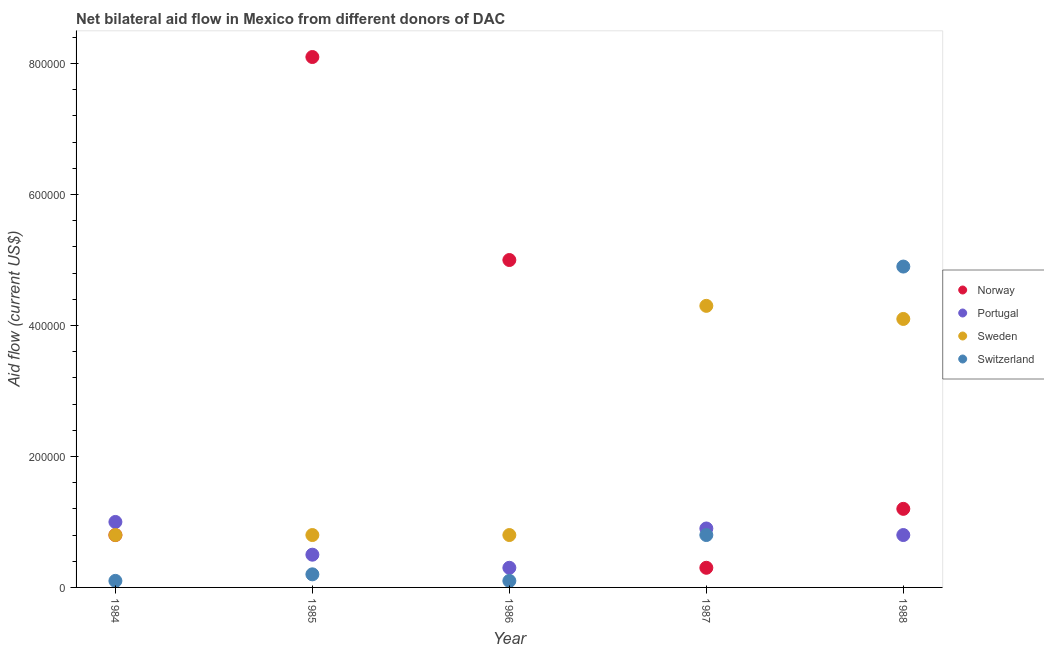Is the number of dotlines equal to the number of legend labels?
Your answer should be compact. Yes. What is the amount of aid given by norway in 1988?
Offer a terse response. 1.20e+05. Across all years, what is the maximum amount of aid given by norway?
Your answer should be very brief. 8.10e+05. Across all years, what is the minimum amount of aid given by switzerland?
Give a very brief answer. 10000. What is the total amount of aid given by portugal in the graph?
Give a very brief answer. 3.50e+05. What is the difference between the amount of aid given by sweden in 1984 and that in 1985?
Ensure brevity in your answer.  0. What is the difference between the amount of aid given by portugal in 1987 and the amount of aid given by sweden in 1986?
Provide a succinct answer. 10000. What is the average amount of aid given by sweden per year?
Provide a short and direct response. 2.16e+05. In the year 1988, what is the difference between the amount of aid given by portugal and amount of aid given by switzerland?
Provide a succinct answer. -4.10e+05. Is the amount of aid given by sweden in 1987 less than that in 1988?
Give a very brief answer. No. What is the difference between the highest and the second highest amount of aid given by portugal?
Give a very brief answer. 10000. What is the difference between the highest and the lowest amount of aid given by sweden?
Your answer should be compact. 3.50e+05. In how many years, is the amount of aid given by portugal greater than the average amount of aid given by portugal taken over all years?
Give a very brief answer. 3. Is the sum of the amount of aid given by norway in 1984 and 1987 greater than the maximum amount of aid given by switzerland across all years?
Your response must be concise. No. Is it the case that in every year, the sum of the amount of aid given by sweden and amount of aid given by norway is greater than the sum of amount of aid given by portugal and amount of aid given by switzerland?
Offer a terse response. Yes. Is the amount of aid given by switzerland strictly greater than the amount of aid given by sweden over the years?
Make the answer very short. No. Are the values on the major ticks of Y-axis written in scientific E-notation?
Give a very brief answer. No. Does the graph contain any zero values?
Your answer should be compact. No. Does the graph contain grids?
Offer a very short reply. No. Where does the legend appear in the graph?
Your answer should be very brief. Center right. How are the legend labels stacked?
Make the answer very short. Vertical. What is the title of the graph?
Offer a very short reply. Net bilateral aid flow in Mexico from different donors of DAC. Does "Debt policy" appear as one of the legend labels in the graph?
Provide a succinct answer. No. What is the label or title of the X-axis?
Provide a succinct answer. Year. What is the label or title of the Y-axis?
Your answer should be compact. Aid flow (current US$). What is the Aid flow (current US$) of Switzerland in 1984?
Ensure brevity in your answer.  10000. What is the Aid flow (current US$) of Norway in 1985?
Offer a very short reply. 8.10e+05. What is the Aid flow (current US$) in Sweden in 1985?
Ensure brevity in your answer.  8.00e+04. What is the Aid flow (current US$) of Norway in 1986?
Your response must be concise. 5.00e+05. What is the Aid flow (current US$) in Sweden in 1986?
Give a very brief answer. 8.00e+04. What is the Aid flow (current US$) in Switzerland in 1986?
Offer a very short reply. 10000. What is the Aid flow (current US$) in Norway in 1988?
Provide a succinct answer. 1.20e+05. What is the Aid flow (current US$) of Portugal in 1988?
Give a very brief answer. 8.00e+04. Across all years, what is the maximum Aid flow (current US$) of Norway?
Your answer should be very brief. 8.10e+05. Across all years, what is the minimum Aid flow (current US$) of Portugal?
Make the answer very short. 3.00e+04. What is the total Aid flow (current US$) in Norway in the graph?
Your answer should be very brief. 1.54e+06. What is the total Aid flow (current US$) of Portugal in the graph?
Your response must be concise. 3.50e+05. What is the total Aid flow (current US$) of Sweden in the graph?
Your answer should be very brief. 1.08e+06. What is the difference between the Aid flow (current US$) in Norway in 1984 and that in 1985?
Provide a succinct answer. -7.30e+05. What is the difference between the Aid flow (current US$) in Sweden in 1984 and that in 1985?
Give a very brief answer. 0. What is the difference between the Aid flow (current US$) in Switzerland in 1984 and that in 1985?
Provide a succinct answer. -10000. What is the difference between the Aid flow (current US$) in Norway in 1984 and that in 1986?
Offer a terse response. -4.20e+05. What is the difference between the Aid flow (current US$) in Portugal in 1984 and that in 1986?
Make the answer very short. 7.00e+04. What is the difference between the Aid flow (current US$) of Norway in 1984 and that in 1987?
Offer a terse response. 5.00e+04. What is the difference between the Aid flow (current US$) of Portugal in 1984 and that in 1987?
Offer a terse response. 10000. What is the difference between the Aid flow (current US$) of Sweden in 1984 and that in 1987?
Offer a terse response. -3.50e+05. What is the difference between the Aid flow (current US$) of Switzerland in 1984 and that in 1987?
Your response must be concise. -7.00e+04. What is the difference between the Aid flow (current US$) in Norway in 1984 and that in 1988?
Your response must be concise. -4.00e+04. What is the difference between the Aid flow (current US$) of Sweden in 1984 and that in 1988?
Offer a terse response. -3.30e+05. What is the difference between the Aid flow (current US$) in Switzerland in 1984 and that in 1988?
Ensure brevity in your answer.  -4.80e+05. What is the difference between the Aid flow (current US$) of Norway in 1985 and that in 1986?
Provide a short and direct response. 3.10e+05. What is the difference between the Aid flow (current US$) of Switzerland in 1985 and that in 1986?
Provide a short and direct response. 10000. What is the difference between the Aid flow (current US$) of Norway in 1985 and that in 1987?
Make the answer very short. 7.80e+05. What is the difference between the Aid flow (current US$) in Sweden in 1985 and that in 1987?
Offer a very short reply. -3.50e+05. What is the difference between the Aid flow (current US$) in Switzerland in 1985 and that in 1987?
Your response must be concise. -6.00e+04. What is the difference between the Aid flow (current US$) of Norway in 1985 and that in 1988?
Your answer should be very brief. 6.90e+05. What is the difference between the Aid flow (current US$) in Sweden in 1985 and that in 1988?
Make the answer very short. -3.30e+05. What is the difference between the Aid flow (current US$) in Switzerland in 1985 and that in 1988?
Give a very brief answer. -4.70e+05. What is the difference between the Aid flow (current US$) of Portugal in 1986 and that in 1987?
Provide a succinct answer. -6.00e+04. What is the difference between the Aid flow (current US$) of Sweden in 1986 and that in 1987?
Keep it short and to the point. -3.50e+05. What is the difference between the Aid flow (current US$) of Portugal in 1986 and that in 1988?
Keep it short and to the point. -5.00e+04. What is the difference between the Aid flow (current US$) in Sweden in 1986 and that in 1988?
Keep it short and to the point. -3.30e+05. What is the difference between the Aid flow (current US$) in Switzerland in 1986 and that in 1988?
Provide a short and direct response. -4.80e+05. What is the difference between the Aid flow (current US$) in Norway in 1987 and that in 1988?
Offer a terse response. -9.00e+04. What is the difference between the Aid flow (current US$) in Portugal in 1987 and that in 1988?
Provide a short and direct response. 10000. What is the difference between the Aid flow (current US$) of Switzerland in 1987 and that in 1988?
Give a very brief answer. -4.10e+05. What is the difference between the Aid flow (current US$) in Norway in 1984 and the Aid flow (current US$) in Portugal in 1985?
Provide a succinct answer. 3.00e+04. What is the difference between the Aid flow (current US$) of Norway in 1984 and the Aid flow (current US$) of Sweden in 1985?
Offer a terse response. 0. What is the difference between the Aid flow (current US$) of Portugal in 1984 and the Aid flow (current US$) of Sweden in 1985?
Offer a terse response. 2.00e+04. What is the difference between the Aid flow (current US$) of Sweden in 1984 and the Aid flow (current US$) of Switzerland in 1985?
Offer a terse response. 6.00e+04. What is the difference between the Aid flow (current US$) of Norway in 1984 and the Aid flow (current US$) of Portugal in 1986?
Provide a succinct answer. 5.00e+04. What is the difference between the Aid flow (current US$) in Portugal in 1984 and the Aid flow (current US$) in Sweden in 1986?
Give a very brief answer. 2.00e+04. What is the difference between the Aid flow (current US$) of Portugal in 1984 and the Aid flow (current US$) of Switzerland in 1986?
Provide a short and direct response. 9.00e+04. What is the difference between the Aid flow (current US$) of Norway in 1984 and the Aid flow (current US$) of Sweden in 1987?
Make the answer very short. -3.50e+05. What is the difference between the Aid flow (current US$) of Portugal in 1984 and the Aid flow (current US$) of Sweden in 1987?
Keep it short and to the point. -3.30e+05. What is the difference between the Aid flow (current US$) of Portugal in 1984 and the Aid flow (current US$) of Switzerland in 1987?
Your response must be concise. 2.00e+04. What is the difference between the Aid flow (current US$) in Norway in 1984 and the Aid flow (current US$) in Sweden in 1988?
Offer a very short reply. -3.30e+05. What is the difference between the Aid flow (current US$) of Norway in 1984 and the Aid flow (current US$) of Switzerland in 1988?
Your answer should be compact. -4.10e+05. What is the difference between the Aid flow (current US$) in Portugal in 1984 and the Aid flow (current US$) in Sweden in 1988?
Make the answer very short. -3.10e+05. What is the difference between the Aid flow (current US$) in Portugal in 1984 and the Aid flow (current US$) in Switzerland in 1988?
Your response must be concise. -3.90e+05. What is the difference between the Aid flow (current US$) of Sweden in 1984 and the Aid flow (current US$) of Switzerland in 1988?
Provide a short and direct response. -4.10e+05. What is the difference between the Aid flow (current US$) of Norway in 1985 and the Aid flow (current US$) of Portugal in 1986?
Make the answer very short. 7.80e+05. What is the difference between the Aid flow (current US$) in Norway in 1985 and the Aid flow (current US$) in Sweden in 1986?
Your response must be concise. 7.30e+05. What is the difference between the Aid flow (current US$) of Portugal in 1985 and the Aid flow (current US$) of Sweden in 1986?
Your answer should be very brief. -3.00e+04. What is the difference between the Aid flow (current US$) of Portugal in 1985 and the Aid flow (current US$) of Switzerland in 1986?
Offer a very short reply. 4.00e+04. What is the difference between the Aid flow (current US$) of Norway in 1985 and the Aid flow (current US$) of Portugal in 1987?
Your response must be concise. 7.20e+05. What is the difference between the Aid flow (current US$) of Norway in 1985 and the Aid flow (current US$) of Switzerland in 1987?
Provide a short and direct response. 7.30e+05. What is the difference between the Aid flow (current US$) of Portugal in 1985 and the Aid flow (current US$) of Sweden in 1987?
Give a very brief answer. -3.80e+05. What is the difference between the Aid flow (current US$) of Portugal in 1985 and the Aid flow (current US$) of Switzerland in 1987?
Your answer should be compact. -3.00e+04. What is the difference between the Aid flow (current US$) of Norway in 1985 and the Aid flow (current US$) of Portugal in 1988?
Provide a short and direct response. 7.30e+05. What is the difference between the Aid flow (current US$) in Norway in 1985 and the Aid flow (current US$) in Sweden in 1988?
Your response must be concise. 4.00e+05. What is the difference between the Aid flow (current US$) of Portugal in 1985 and the Aid flow (current US$) of Sweden in 1988?
Ensure brevity in your answer.  -3.60e+05. What is the difference between the Aid flow (current US$) of Portugal in 1985 and the Aid flow (current US$) of Switzerland in 1988?
Provide a short and direct response. -4.40e+05. What is the difference between the Aid flow (current US$) of Sweden in 1985 and the Aid flow (current US$) of Switzerland in 1988?
Offer a terse response. -4.10e+05. What is the difference between the Aid flow (current US$) of Portugal in 1986 and the Aid flow (current US$) of Sweden in 1987?
Make the answer very short. -4.00e+05. What is the difference between the Aid flow (current US$) in Norway in 1986 and the Aid flow (current US$) in Portugal in 1988?
Your response must be concise. 4.20e+05. What is the difference between the Aid flow (current US$) in Portugal in 1986 and the Aid flow (current US$) in Sweden in 1988?
Keep it short and to the point. -3.80e+05. What is the difference between the Aid flow (current US$) in Portugal in 1986 and the Aid flow (current US$) in Switzerland in 1988?
Offer a very short reply. -4.60e+05. What is the difference between the Aid flow (current US$) in Sweden in 1986 and the Aid flow (current US$) in Switzerland in 1988?
Provide a short and direct response. -4.10e+05. What is the difference between the Aid flow (current US$) of Norway in 1987 and the Aid flow (current US$) of Portugal in 1988?
Give a very brief answer. -5.00e+04. What is the difference between the Aid flow (current US$) in Norway in 1987 and the Aid flow (current US$) in Sweden in 1988?
Your answer should be very brief. -3.80e+05. What is the difference between the Aid flow (current US$) in Norway in 1987 and the Aid flow (current US$) in Switzerland in 1988?
Provide a short and direct response. -4.60e+05. What is the difference between the Aid flow (current US$) in Portugal in 1987 and the Aid flow (current US$) in Sweden in 1988?
Your answer should be compact. -3.20e+05. What is the difference between the Aid flow (current US$) in Portugal in 1987 and the Aid flow (current US$) in Switzerland in 1988?
Keep it short and to the point. -4.00e+05. What is the difference between the Aid flow (current US$) of Sweden in 1987 and the Aid flow (current US$) of Switzerland in 1988?
Keep it short and to the point. -6.00e+04. What is the average Aid flow (current US$) of Norway per year?
Provide a short and direct response. 3.08e+05. What is the average Aid flow (current US$) in Sweden per year?
Your response must be concise. 2.16e+05. What is the average Aid flow (current US$) in Switzerland per year?
Offer a terse response. 1.22e+05. In the year 1984, what is the difference between the Aid flow (current US$) in Norway and Aid flow (current US$) in Sweden?
Ensure brevity in your answer.  0. In the year 1984, what is the difference between the Aid flow (current US$) in Sweden and Aid flow (current US$) in Switzerland?
Your answer should be very brief. 7.00e+04. In the year 1985, what is the difference between the Aid flow (current US$) of Norway and Aid flow (current US$) of Portugal?
Ensure brevity in your answer.  7.60e+05. In the year 1985, what is the difference between the Aid flow (current US$) of Norway and Aid flow (current US$) of Sweden?
Keep it short and to the point. 7.30e+05. In the year 1985, what is the difference between the Aid flow (current US$) of Norway and Aid flow (current US$) of Switzerland?
Provide a succinct answer. 7.90e+05. In the year 1985, what is the difference between the Aid flow (current US$) of Portugal and Aid flow (current US$) of Switzerland?
Provide a short and direct response. 3.00e+04. In the year 1985, what is the difference between the Aid flow (current US$) of Sweden and Aid flow (current US$) of Switzerland?
Keep it short and to the point. 6.00e+04. In the year 1986, what is the difference between the Aid flow (current US$) in Norway and Aid flow (current US$) in Portugal?
Keep it short and to the point. 4.70e+05. In the year 1986, what is the difference between the Aid flow (current US$) in Norway and Aid flow (current US$) in Sweden?
Keep it short and to the point. 4.20e+05. In the year 1986, what is the difference between the Aid flow (current US$) of Portugal and Aid flow (current US$) of Sweden?
Make the answer very short. -5.00e+04. In the year 1987, what is the difference between the Aid flow (current US$) in Norway and Aid flow (current US$) in Portugal?
Provide a short and direct response. -6.00e+04. In the year 1987, what is the difference between the Aid flow (current US$) of Norway and Aid flow (current US$) of Sweden?
Give a very brief answer. -4.00e+05. In the year 1987, what is the difference between the Aid flow (current US$) in Norway and Aid flow (current US$) in Switzerland?
Keep it short and to the point. -5.00e+04. In the year 1987, what is the difference between the Aid flow (current US$) of Portugal and Aid flow (current US$) of Sweden?
Your answer should be compact. -3.40e+05. In the year 1987, what is the difference between the Aid flow (current US$) of Portugal and Aid flow (current US$) of Switzerland?
Your answer should be compact. 10000. In the year 1988, what is the difference between the Aid flow (current US$) in Norway and Aid flow (current US$) in Portugal?
Offer a very short reply. 4.00e+04. In the year 1988, what is the difference between the Aid flow (current US$) of Norway and Aid flow (current US$) of Sweden?
Your answer should be compact. -2.90e+05. In the year 1988, what is the difference between the Aid flow (current US$) of Norway and Aid flow (current US$) of Switzerland?
Provide a short and direct response. -3.70e+05. In the year 1988, what is the difference between the Aid flow (current US$) in Portugal and Aid flow (current US$) in Sweden?
Keep it short and to the point. -3.30e+05. In the year 1988, what is the difference between the Aid flow (current US$) in Portugal and Aid flow (current US$) in Switzerland?
Your response must be concise. -4.10e+05. In the year 1988, what is the difference between the Aid flow (current US$) of Sweden and Aid flow (current US$) of Switzerland?
Make the answer very short. -8.00e+04. What is the ratio of the Aid flow (current US$) of Norway in 1984 to that in 1985?
Give a very brief answer. 0.1. What is the ratio of the Aid flow (current US$) in Norway in 1984 to that in 1986?
Give a very brief answer. 0.16. What is the ratio of the Aid flow (current US$) of Norway in 1984 to that in 1987?
Your answer should be compact. 2.67. What is the ratio of the Aid flow (current US$) in Sweden in 1984 to that in 1987?
Offer a terse response. 0.19. What is the ratio of the Aid flow (current US$) of Norway in 1984 to that in 1988?
Offer a very short reply. 0.67. What is the ratio of the Aid flow (current US$) in Sweden in 1984 to that in 1988?
Ensure brevity in your answer.  0.2. What is the ratio of the Aid flow (current US$) of Switzerland in 1984 to that in 1988?
Offer a terse response. 0.02. What is the ratio of the Aid flow (current US$) in Norway in 1985 to that in 1986?
Keep it short and to the point. 1.62. What is the ratio of the Aid flow (current US$) of Sweden in 1985 to that in 1986?
Offer a terse response. 1. What is the ratio of the Aid flow (current US$) in Switzerland in 1985 to that in 1986?
Provide a succinct answer. 2. What is the ratio of the Aid flow (current US$) in Portugal in 1985 to that in 1987?
Ensure brevity in your answer.  0.56. What is the ratio of the Aid flow (current US$) of Sweden in 1985 to that in 1987?
Your response must be concise. 0.19. What is the ratio of the Aid flow (current US$) of Norway in 1985 to that in 1988?
Make the answer very short. 6.75. What is the ratio of the Aid flow (current US$) of Portugal in 1985 to that in 1988?
Provide a short and direct response. 0.62. What is the ratio of the Aid flow (current US$) of Sweden in 1985 to that in 1988?
Ensure brevity in your answer.  0.2. What is the ratio of the Aid flow (current US$) in Switzerland in 1985 to that in 1988?
Provide a succinct answer. 0.04. What is the ratio of the Aid flow (current US$) in Norway in 1986 to that in 1987?
Your answer should be compact. 16.67. What is the ratio of the Aid flow (current US$) in Sweden in 1986 to that in 1987?
Offer a very short reply. 0.19. What is the ratio of the Aid flow (current US$) in Switzerland in 1986 to that in 1987?
Provide a succinct answer. 0.12. What is the ratio of the Aid flow (current US$) of Norway in 1986 to that in 1988?
Provide a short and direct response. 4.17. What is the ratio of the Aid flow (current US$) of Portugal in 1986 to that in 1988?
Your answer should be very brief. 0.38. What is the ratio of the Aid flow (current US$) of Sweden in 1986 to that in 1988?
Make the answer very short. 0.2. What is the ratio of the Aid flow (current US$) in Switzerland in 1986 to that in 1988?
Ensure brevity in your answer.  0.02. What is the ratio of the Aid flow (current US$) of Portugal in 1987 to that in 1988?
Make the answer very short. 1.12. What is the ratio of the Aid flow (current US$) of Sweden in 1987 to that in 1988?
Your response must be concise. 1.05. What is the ratio of the Aid flow (current US$) in Switzerland in 1987 to that in 1988?
Your response must be concise. 0.16. What is the difference between the highest and the second highest Aid flow (current US$) of Portugal?
Provide a short and direct response. 10000. What is the difference between the highest and the second highest Aid flow (current US$) in Sweden?
Your answer should be very brief. 2.00e+04. What is the difference between the highest and the lowest Aid flow (current US$) in Norway?
Your answer should be compact. 7.80e+05. What is the difference between the highest and the lowest Aid flow (current US$) in Switzerland?
Provide a succinct answer. 4.80e+05. 